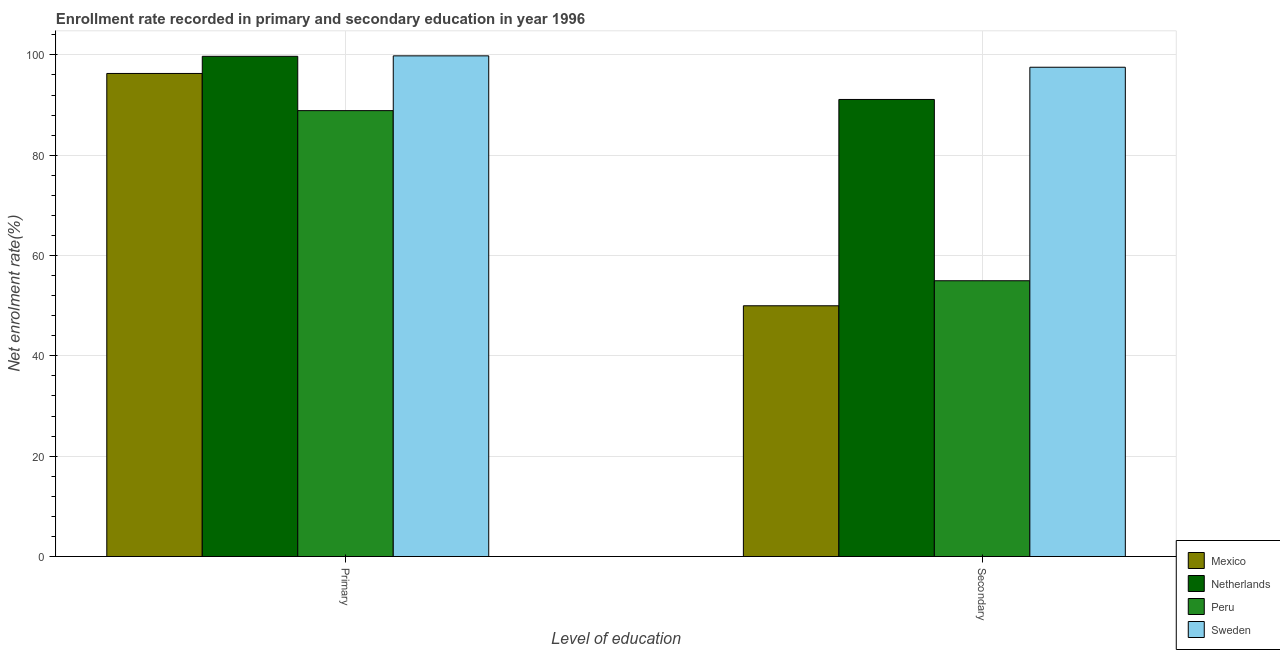Are the number of bars on each tick of the X-axis equal?
Your answer should be compact. Yes. How many bars are there on the 2nd tick from the left?
Your answer should be compact. 4. What is the label of the 2nd group of bars from the left?
Make the answer very short. Secondary. What is the enrollment rate in secondary education in Sweden?
Your answer should be compact. 97.53. Across all countries, what is the maximum enrollment rate in primary education?
Keep it short and to the point. 99.8. Across all countries, what is the minimum enrollment rate in primary education?
Keep it short and to the point. 88.88. In which country was the enrollment rate in secondary education maximum?
Provide a short and direct response. Sweden. In which country was the enrollment rate in secondary education minimum?
Ensure brevity in your answer.  Mexico. What is the total enrollment rate in secondary education in the graph?
Your answer should be very brief. 293.6. What is the difference between the enrollment rate in primary education in Peru and that in Mexico?
Your response must be concise. -7.41. What is the difference between the enrollment rate in secondary education in Netherlands and the enrollment rate in primary education in Mexico?
Your answer should be compact. -5.18. What is the average enrollment rate in primary education per country?
Offer a terse response. 96.17. What is the difference between the enrollment rate in secondary education and enrollment rate in primary education in Mexico?
Give a very brief answer. -46.31. What is the ratio of the enrollment rate in secondary education in Mexico to that in Sweden?
Your answer should be compact. 0.51. Is the enrollment rate in primary education in Peru less than that in Netherlands?
Offer a terse response. Yes. In how many countries, is the enrollment rate in primary education greater than the average enrollment rate in primary education taken over all countries?
Provide a short and direct response. 3. What does the 4th bar from the left in Secondary represents?
Offer a very short reply. Sweden. How many bars are there?
Your answer should be very brief. 8. Are all the bars in the graph horizontal?
Your response must be concise. No. How many legend labels are there?
Offer a very short reply. 4. How are the legend labels stacked?
Your answer should be very brief. Vertical. What is the title of the graph?
Your answer should be compact. Enrollment rate recorded in primary and secondary education in year 1996. What is the label or title of the X-axis?
Offer a terse response. Level of education. What is the label or title of the Y-axis?
Ensure brevity in your answer.  Net enrolment rate(%). What is the Net enrolment rate(%) of Mexico in Primary?
Offer a very short reply. 96.3. What is the Net enrolment rate(%) of Netherlands in Primary?
Give a very brief answer. 99.71. What is the Net enrolment rate(%) in Peru in Primary?
Ensure brevity in your answer.  88.88. What is the Net enrolment rate(%) of Sweden in Primary?
Ensure brevity in your answer.  99.8. What is the Net enrolment rate(%) of Mexico in Secondary?
Your response must be concise. 49.99. What is the Net enrolment rate(%) of Netherlands in Secondary?
Provide a succinct answer. 91.11. What is the Net enrolment rate(%) in Peru in Secondary?
Offer a terse response. 54.97. What is the Net enrolment rate(%) of Sweden in Secondary?
Your answer should be compact. 97.53. Across all Level of education, what is the maximum Net enrolment rate(%) in Mexico?
Offer a terse response. 96.3. Across all Level of education, what is the maximum Net enrolment rate(%) of Netherlands?
Your answer should be very brief. 99.71. Across all Level of education, what is the maximum Net enrolment rate(%) of Peru?
Ensure brevity in your answer.  88.88. Across all Level of education, what is the maximum Net enrolment rate(%) of Sweden?
Make the answer very short. 99.8. Across all Level of education, what is the minimum Net enrolment rate(%) in Mexico?
Provide a succinct answer. 49.99. Across all Level of education, what is the minimum Net enrolment rate(%) in Netherlands?
Make the answer very short. 91.11. Across all Level of education, what is the minimum Net enrolment rate(%) of Peru?
Provide a succinct answer. 54.97. Across all Level of education, what is the minimum Net enrolment rate(%) of Sweden?
Give a very brief answer. 97.53. What is the total Net enrolment rate(%) in Mexico in the graph?
Your response must be concise. 146.28. What is the total Net enrolment rate(%) of Netherlands in the graph?
Make the answer very short. 190.82. What is the total Net enrolment rate(%) in Peru in the graph?
Keep it short and to the point. 143.86. What is the total Net enrolment rate(%) of Sweden in the graph?
Your answer should be compact. 197.34. What is the difference between the Net enrolment rate(%) in Mexico in Primary and that in Secondary?
Ensure brevity in your answer.  46.31. What is the difference between the Net enrolment rate(%) in Netherlands in Primary and that in Secondary?
Offer a very short reply. 8.6. What is the difference between the Net enrolment rate(%) of Peru in Primary and that in Secondary?
Keep it short and to the point. 33.91. What is the difference between the Net enrolment rate(%) of Sweden in Primary and that in Secondary?
Your response must be concise. 2.27. What is the difference between the Net enrolment rate(%) in Mexico in Primary and the Net enrolment rate(%) in Netherlands in Secondary?
Your response must be concise. 5.18. What is the difference between the Net enrolment rate(%) in Mexico in Primary and the Net enrolment rate(%) in Peru in Secondary?
Your answer should be compact. 41.32. What is the difference between the Net enrolment rate(%) of Mexico in Primary and the Net enrolment rate(%) of Sweden in Secondary?
Provide a succinct answer. -1.24. What is the difference between the Net enrolment rate(%) of Netherlands in Primary and the Net enrolment rate(%) of Peru in Secondary?
Give a very brief answer. 44.74. What is the difference between the Net enrolment rate(%) in Netherlands in Primary and the Net enrolment rate(%) in Sweden in Secondary?
Your answer should be very brief. 2.18. What is the difference between the Net enrolment rate(%) in Peru in Primary and the Net enrolment rate(%) in Sweden in Secondary?
Your response must be concise. -8.65. What is the average Net enrolment rate(%) of Mexico per Level of education?
Keep it short and to the point. 73.14. What is the average Net enrolment rate(%) in Netherlands per Level of education?
Provide a short and direct response. 95.41. What is the average Net enrolment rate(%) of Peru per Level of education?
Your answer should be compact. 71.93. What is the average Net enrolment rate(%) in Sweden per Level of education?
Provide a succinct answer. 98.67. What is the difference between the Net enrolment rate(%) of Mexico and Net enrolment rate(%) of Netherlands in Primary?
Offer a terse response. -3.42. What is the difference between the Net enrolment rate(%) of Mexico and Net enrolment rate(%) of Peru in Primary?
Your response must be concise. 7.41. What is the difference between the Net enrolment rate(%) in Mexico and Net enrolment rate(%) in Sweden in Primary?
Make the answer very short. -3.51. What is the difference between the Net enrolment rate(%) in Netherlands and Net enrolment rate(%) in Peru in Primary?
Give a very brief answer. 10.83. What is the difference between the Net enrolment rate(%) in Netherlands and Net enrolment rate(%) in Sweden in Primary?
Provide a short and direct response. -0.09. What is the difference between the Net enrolment rate(%) of Peru and Net enrolment rate(%) of Sweden in Primary?
Provide a succinct answer. -10.92. What is the difference between the Net enrolment rate(%) in Mexico and Net enrolment rate(%) in Netherlands in Secondary?
Make the answer very short. -41.12. What is the difference between the Net enrolment rate(%) of Mexico and Net enrolment rate(%) of Peru in Secondary?
Provide a short and direct response. -4.99. What is the difference between the Net enrolment rate(%) of Mexico and Net enrolment rate(%) of Sweden in Secondary?
Your answer should be very brief. -47.55. What is the difference between the Net enrolment rate(%) in Netherlands and Net enrolment rate(%) in Peru in Secondary?
Offer a terse response. 36.14. What is the difference between the Net enrolment rate(%) in Netherlands and Net enrolment rate(%) in Sweden in Secondary?
Your answer should be very brief. -6.42. What is the difference between the Net enrolment rate(%) of Peru and Net enrolment rate(%) of Sweden in Secondary?
Provide a succinct answer. -42.56. What is the ratio of the Net enrolment rate(%) in Mexico in Primary to that in Secondary?
Your response must be concise. 1.93. What is the ratio of the Net enrolment rate(%) of Netherlands in Primary to that in Secondary?
Offer a very short reply. 1.09. What is the ratio of the Net enrolment rate(%) of Peru in Primary to that in Secondary?
Give a very brief answer. 1.62. What is the ratio of the Net enrolment rate(%) of Sweden in Primary to that in Secondary?
Your answer should be compact. 1.02. What is the difference between the highest and the second highest Net enrolment rate(%) of Mexico?
Offer a very short reply. 46.31. What is the difference between the highest and the second highest Net enrolment rate(%) of Netherlands?
Make the answer very short. 8.6. What is the difference between the highest and the second highest Net enrolment rate(%) of Peru?
Provide a short and direct response. 33.91. What is the difference between the highest and the second highest Net enrolment rate(%) of Sweden?
Your answer should be compact. 2.27. What is the difference between the highest and the lowest Net enrolment rate(%) of Mexico?
Offer a terse response. 46.31. What is the difference between the highest and the lowest Net enrolment rate(%) in Netherlands?
Offer a terse response. 8.6. What is the difference between the highest and the lowest Net enrolment rate(%) in Peru?
Make the answer very short. 33.91. What is the difference between the highest and the lowest Net enrolment rate(%) in Sweden?
Offer a very short reply. 2.27. 